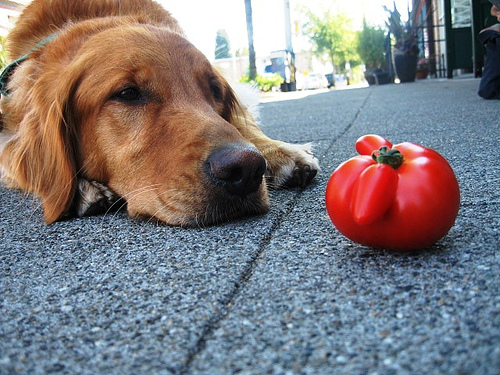<image>
Is the tree behind the dog? Yes. From this viewpoint, the tree is positioned behind the dog, with the dog partially or fully occluding the tree. 